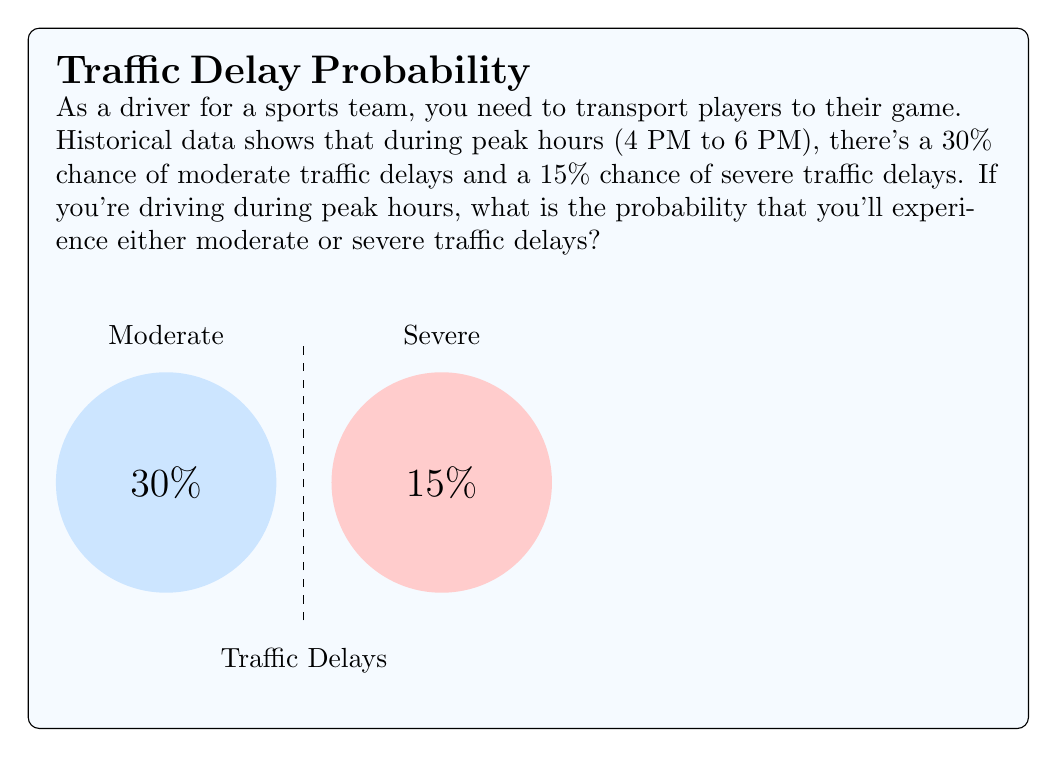Provide a solution to this math problem. Let's approach this step-by-step:

1) We need to find the probability of experiencing either moderate or severe traffic delays.

2) Let's define our events:
   A = Moderate traffic delay
   B = Severe traffic delay

3) We're given:
   P(A) = 30% = 0.30
   P(B) = 15% = 0.15

4) We want to find P(A or B), which is the probability of either A or B occurring.

5) In probability theory, for two events A and B:

   P(A or B) = P(A) + P(B) - P(A and B)

6) However, in this case, we can assume that moderate and severe traffic delays are mutually exclusive events (they can't happen simultaneously).

7) When events are mutually exclusive, P(A and B) = 0, so our formula simplifies to:

   P(A or B) = P(A) + P(B)

8) Now we can simply add the probabilities:

   P(A or B) = 0.30 + 0.15 = 0.45

9) Convert to a percentage:

   0.45 * 100 = 45%

Therefore, the probability of experiencing either moderate or severe traffic delays during peak hours is 45%.
Answer: 45% 